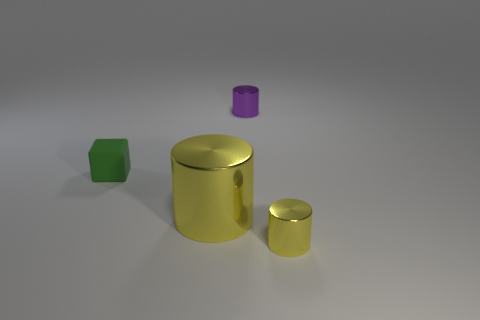Add 3 metal cylinders. How many objects exist? 7 Subtract all blocks. How many objects are left? 3 Subtract 0 cyan cylinders. How many objects are left? 4 Subtract all green matte objects. Subtract all big cylinders. How many objects are left? 2 Add 2 small metal objects. How many small metal objects are left? 4 Add 2 matte blocks. How many matte blocks exist? 3 